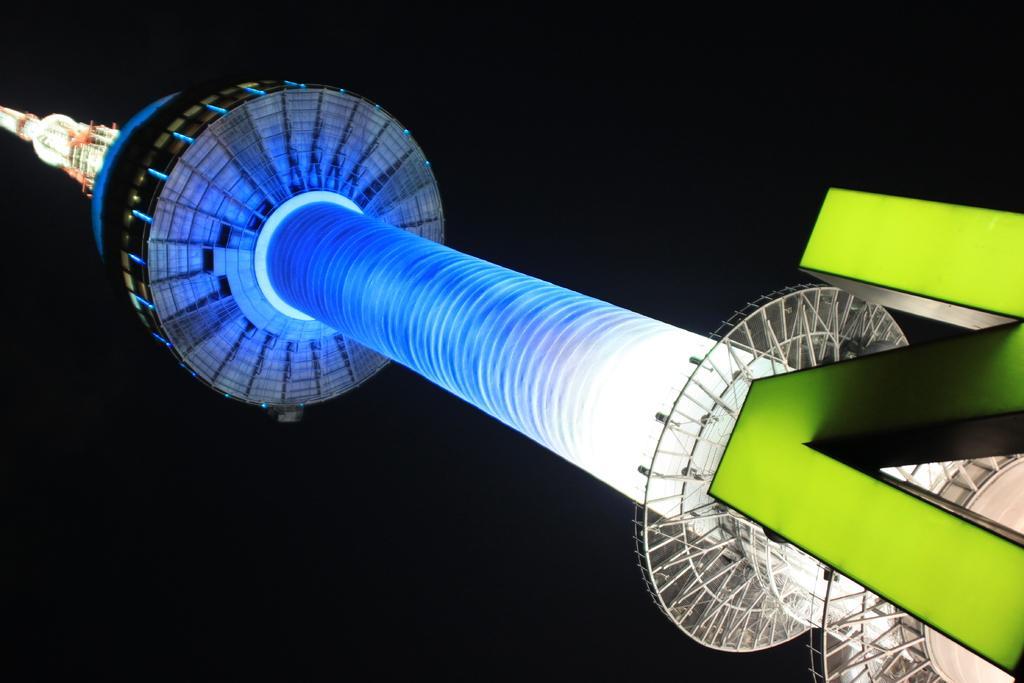In one or two sentences, can you explain what this image depicts? In this image we can see a tower, lights, and a letter n, and the background is dark. 